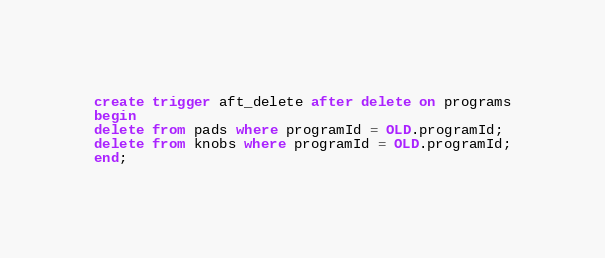Convert code to text. <code><loc_0><loc_0><loc_500><loc_500><_SQL_>create trigger aft_delete after delete on programs
begin
delete from pads where programId = OLD.programId;
delete from knobs where programId = OLD.programId;
end;
</code> 